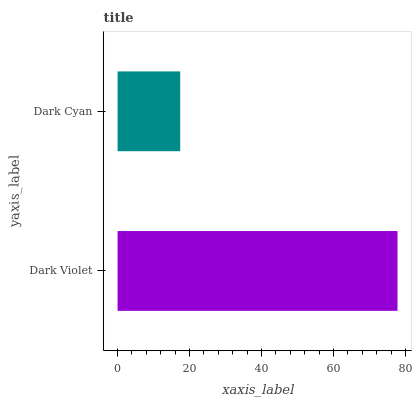Is Dark Cyan the minimum?
Answer yes or no. Yes. Is Dark Violet the maximum?
Answer yes or no. Yes. Is Dark Cyan the maximum?
Answer yes or no. No. Is Dark Violet greater than Dark Cyan?
Answer yes or no. Yes. Is Dark Cyan less than Dark Violet?
Answer yes or no. Yes. Is Dark Cyan greater than Dark Violet?
Answer yes or no. No. Is Dark Violet less than Dark Cyan?
Answer yes or no. No. Is Dark Violet the high median?
Answer yes or no. Yes. Is Dark Cyan the low median?
Answer yes or no. Yes. Is Dark Cyan the high median?
Answer yes or no. No. Is Dark Violet the low median?
Answer yes or no. No. 